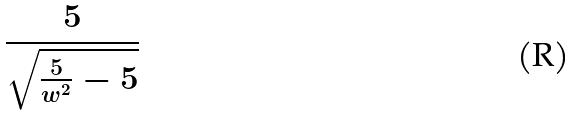<formula> <loc_0><loc_0><loc_500><loc_500>\frac { 5 } { \sqrt { \frac { 5 } { w ^ { 2 } } - 5 } }</formula> 